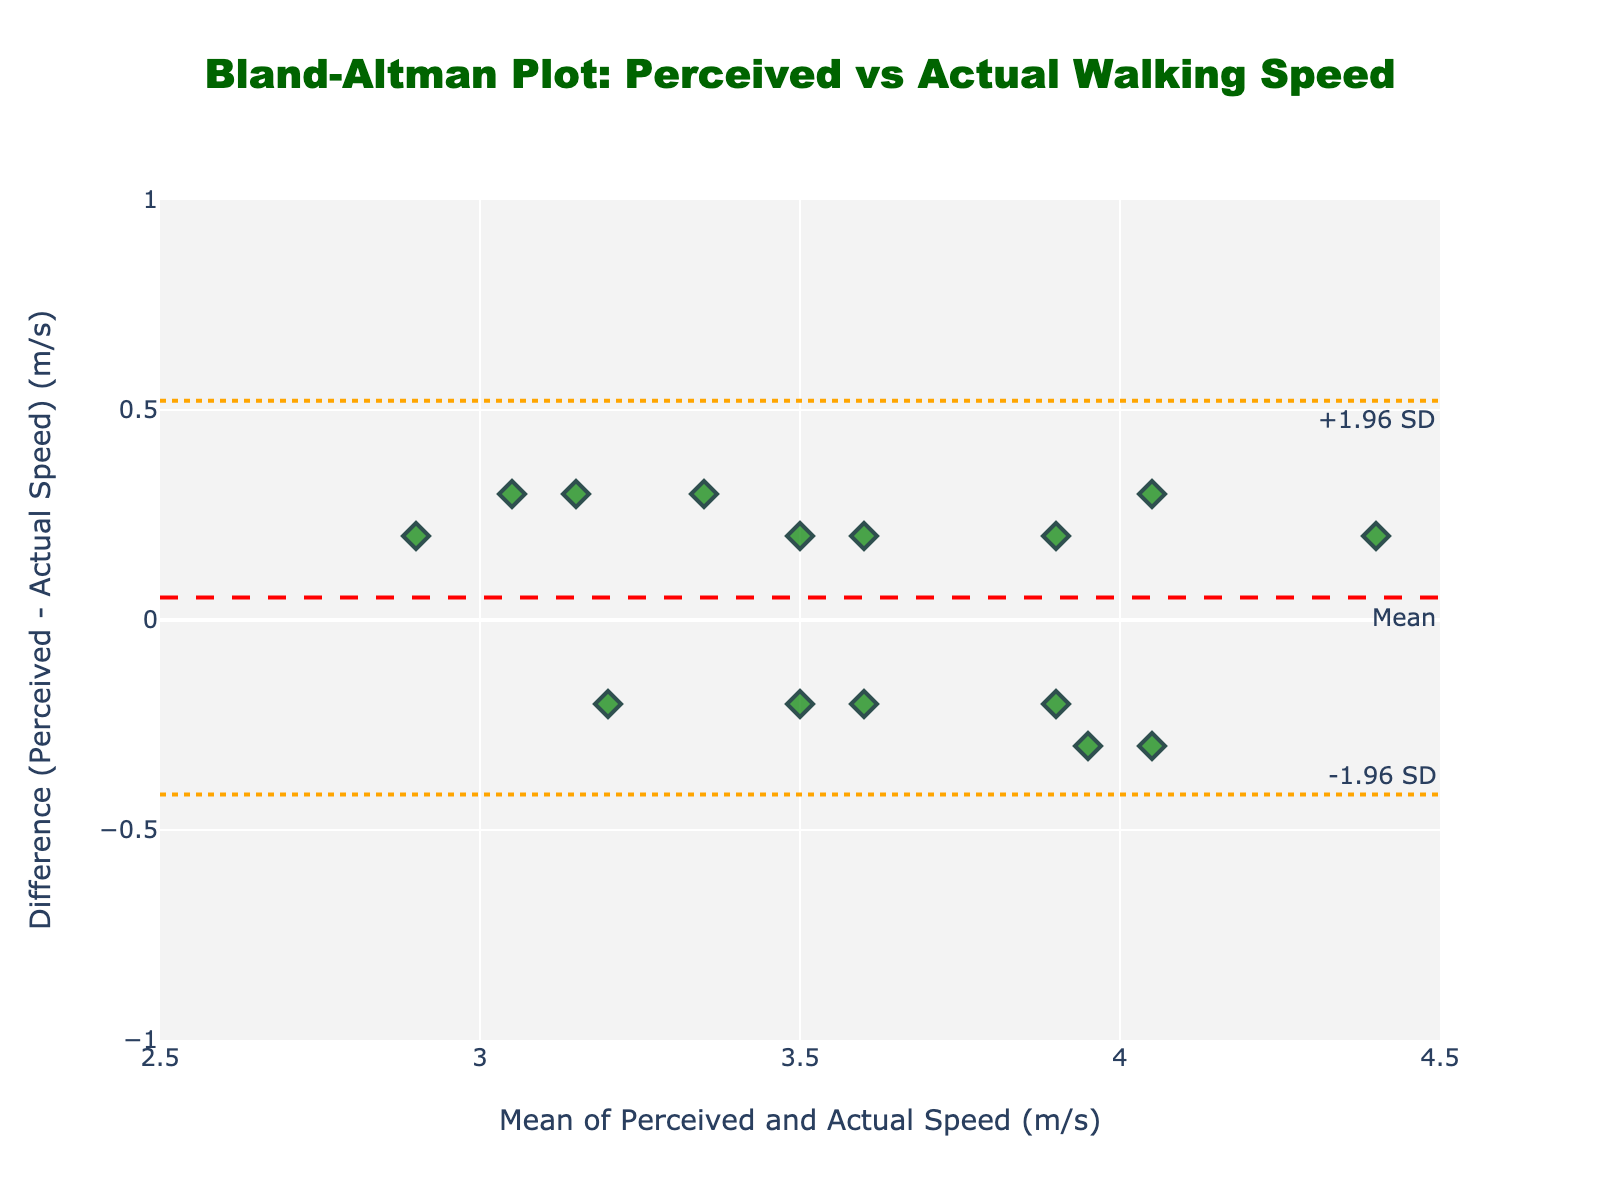What's the title of the figure? The title of the figure is displayed at the top and reads "Bland-Altman Plot: Perceived vs Actual Walking Speed."
Answer: Bland-Altman Plot: Perceived vs Actual Walking Speed What are the x-axis and y-axis labels? The x-axis label is "Mean of Perceived and Actual Speed (m/s)", and the y-axis label is "Difference (Perceived - Actual Speed) (m/s)".
Answer: x-axis: Mean of Perceived and Actual Speed (m/s), y-axis: Difference (Perceived - Actual Speed) (m/s) How many data points are plotted in the figure? By counting the number of markers on the scatter plot, we can see there are 15 data points.
Answer: 15 What is the mean difference between perceived and actual walking speeds? The mean difference is represented by the red dashed horizontal line, which is labeled "Mean". This annotation indicates the position of the mean difference.
Answer: Near 0 What are the limits of agreement? The limits of agreement are shown with dashed dot orange lines, labeled as "+1.96 SD" for the upper limit and "-1.96 SD" for the lower limit.
Answer: Upper: ~0.4, Lower: ~-0.4 Which data point has the highest mean speed and what is its difference? The highest mean speed can be seen at the far right of the x-axis where the mean is highest. This corresponds to around 4.4 m/s on the x-axis and the difference for this point is approximately 0.2 on the y-axis.
Answer: Mean: ~4.4 m/s, Difference: ~0.2 m/s Are all differences within the limits of agreement? By looking at the plot, we compare the spread of the data points with the lines that represent the upper and lower limits of agreement. All points fall within the range of approximately -0.4 to 0.4, ensuring they are all within the limits of agreement.
Answer: Yes Which data point has the largest positive difference between perceived and actual speeds? The largest positive difference is represented by the data point with the highest position on the y-axis. This corresponds to around 0.3 m/s, with the mean being approximately 4.1 m/s.
Answer: Difference: ~0.3 m/s, Mean: ~4.1 m/s What patterns do you observe regarding the distribution of differences relative to mean speeds? The differences appear to be randomly scattered around the mean difference line, with no obvious trend. Most points are clustered within the limits of agreement, suggesting good agreement between perceived and actual speeds.
Answer: Random scatter within limits 